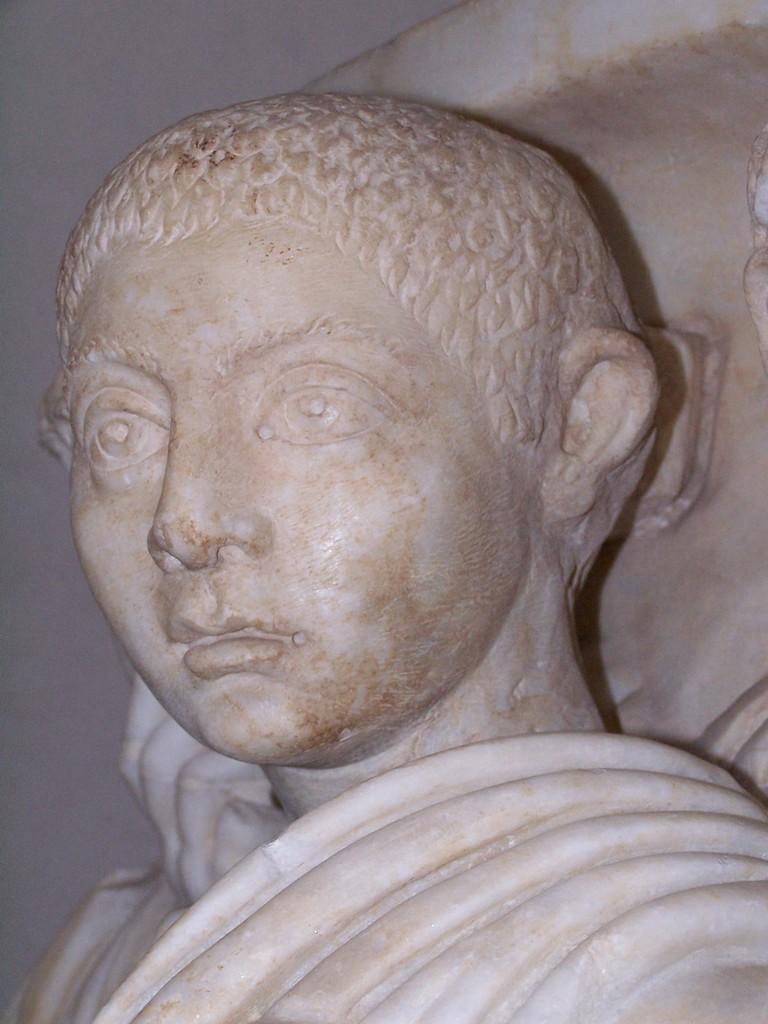Describe this image in one or two sentences. In the image we can see a statue. 